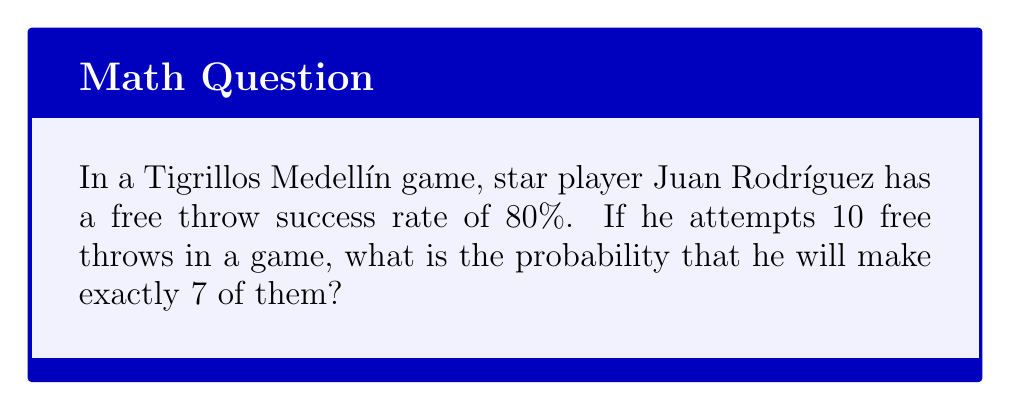Could you help me with this problem? To solve this problem, we'll use the binomial probability distribution, as we're dealing with a fixed number of independent trials (free throws) with two possible outcomes (success or failure) for each trial.

1) Let X be the random variable representing the number of successful free throws.

2) We have:
   n = 10 (number of attempts)
   p = 0.80 (probability of success on each attempt)
   k = 7 (number of successes we're interested in)

3) The binomial probability formula is:

   $$P(X = k) = \binom{n}{k} p^k (1-p)^{n-k}$$

4) Let's calculate each part:

   $$\binom{n}{k} = \binom{10}{7} = \frac{10!}{7!(10-7)!} = 120$$

   $$p^k = 0.80^7 \approx 0.2097$$

   $$(1-p)^{n-k} = 0.20^3 = 0.008$$

5) Now, let's put it all together:

   $$P(X = 7) = 120 \times 0.2097 \times 0.008 \approx 0.2013$$

Therefore, the probability of Juan Rodríguez making exactly 7 out of 10 free throws is approximately 0.2013 or 20.13%.
Answer: 0.2013 